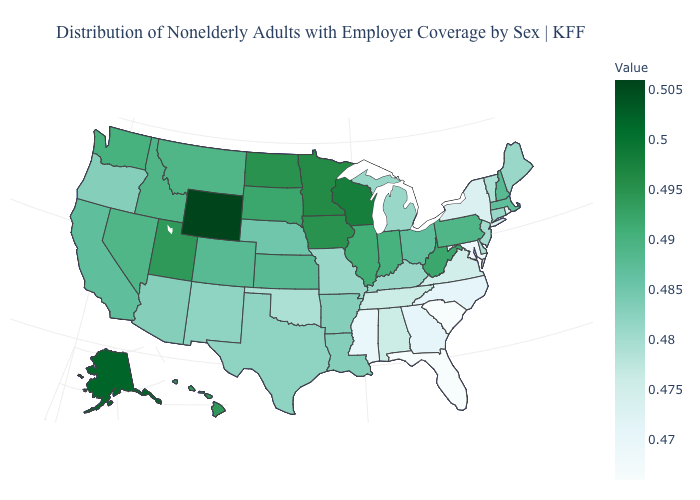Among the states that border Arizona , which have the lowest value?
Keep it brief. New Mexico. Does New Mexico have the lowest value in the West?
Quick response, please. Yes. Which states hav the highest value in the Northeast?
Write a very short answer. Pennsylvania. Among the states that border Missouri , which have the highest value?
Keep it brief. Iowa. Which states hav the highest value in the Northeast?
Concise answer only. Pennsylvania. 